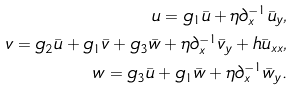<formula> <loc_0><loc_0><loc_500><loc_500>u = g _ { 1 } \bar { u } + \eta \partial _ { x } ^ { - 1 } \bar { u } _ { y } , \\ v = g _ { 2 } \bar { u } + g _ { 1 } \bar { v } + g _ { 3 } \bar { w } + \eta \partial _ { x } ^ { - 1 } \bar { v } _ { y } + h \bar { u } _ { x x } , \\ w = g _ { 3 } \bar { u } + g _ { 1 } \bar { w } + \eta \partial _ { x } ^ { - 1 } \bar { w } _ { y } .</formula> 